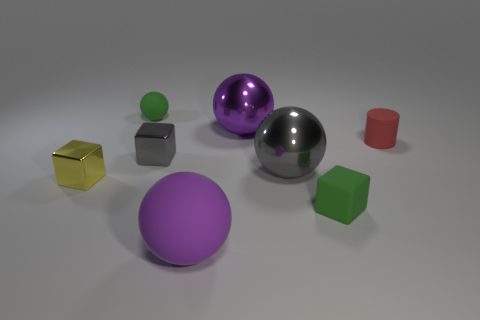Are there any other things that are the same shape as the red rubber object?
Offer a very short reply. No. Is the number of purple cylinders greater than the number of large purple shiny spheres?
Make the answer very short. No. What material is the tiny gray thing?
Ensure brevity in your answer.  Metal. There is a green matte object that is on the right side of the gray metal block; what number of metal balls are behind it?
Keep it short and to the point. 2. There is a big matte sphere; does it have the same color as the metal ball that is behind the small cylinder?
Make the answer very short. Yes. There is a metal thing that is the same size as the gray sphere; what is its color?
Keep it short and to the point. Purple. Are there any tiny green rubber objects that have the same shape as the yellow object?
Make the answer very short. Yes. Are there fewer large gray things than large red rubber cylinders?
Keep it short and to the point. No. What is the color of the object on the left side of the green matte ball?
Provide a short and direct response. Yellow. What shape is the small green matte object that is left of the matte ball that is in front of the small gray block?
Keep it short and to the point. Sphere. 